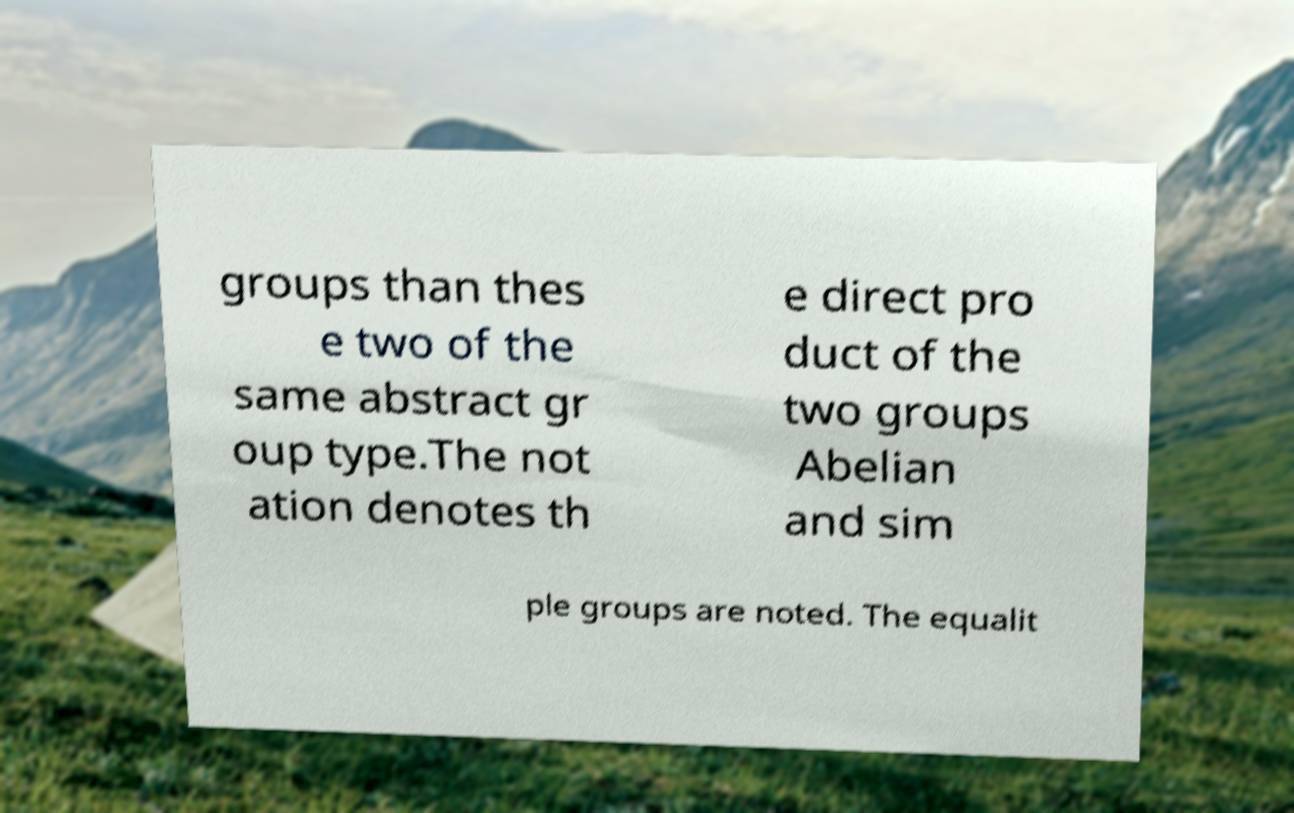There's text embedded in this image that I need extracted. Can you transcribe it verbatim? groups than thes e two of the same abstract gr oup type.The not ation denotes th e direct pro duct of the two groups Abelian and sim ple groups are noted. The equalit 